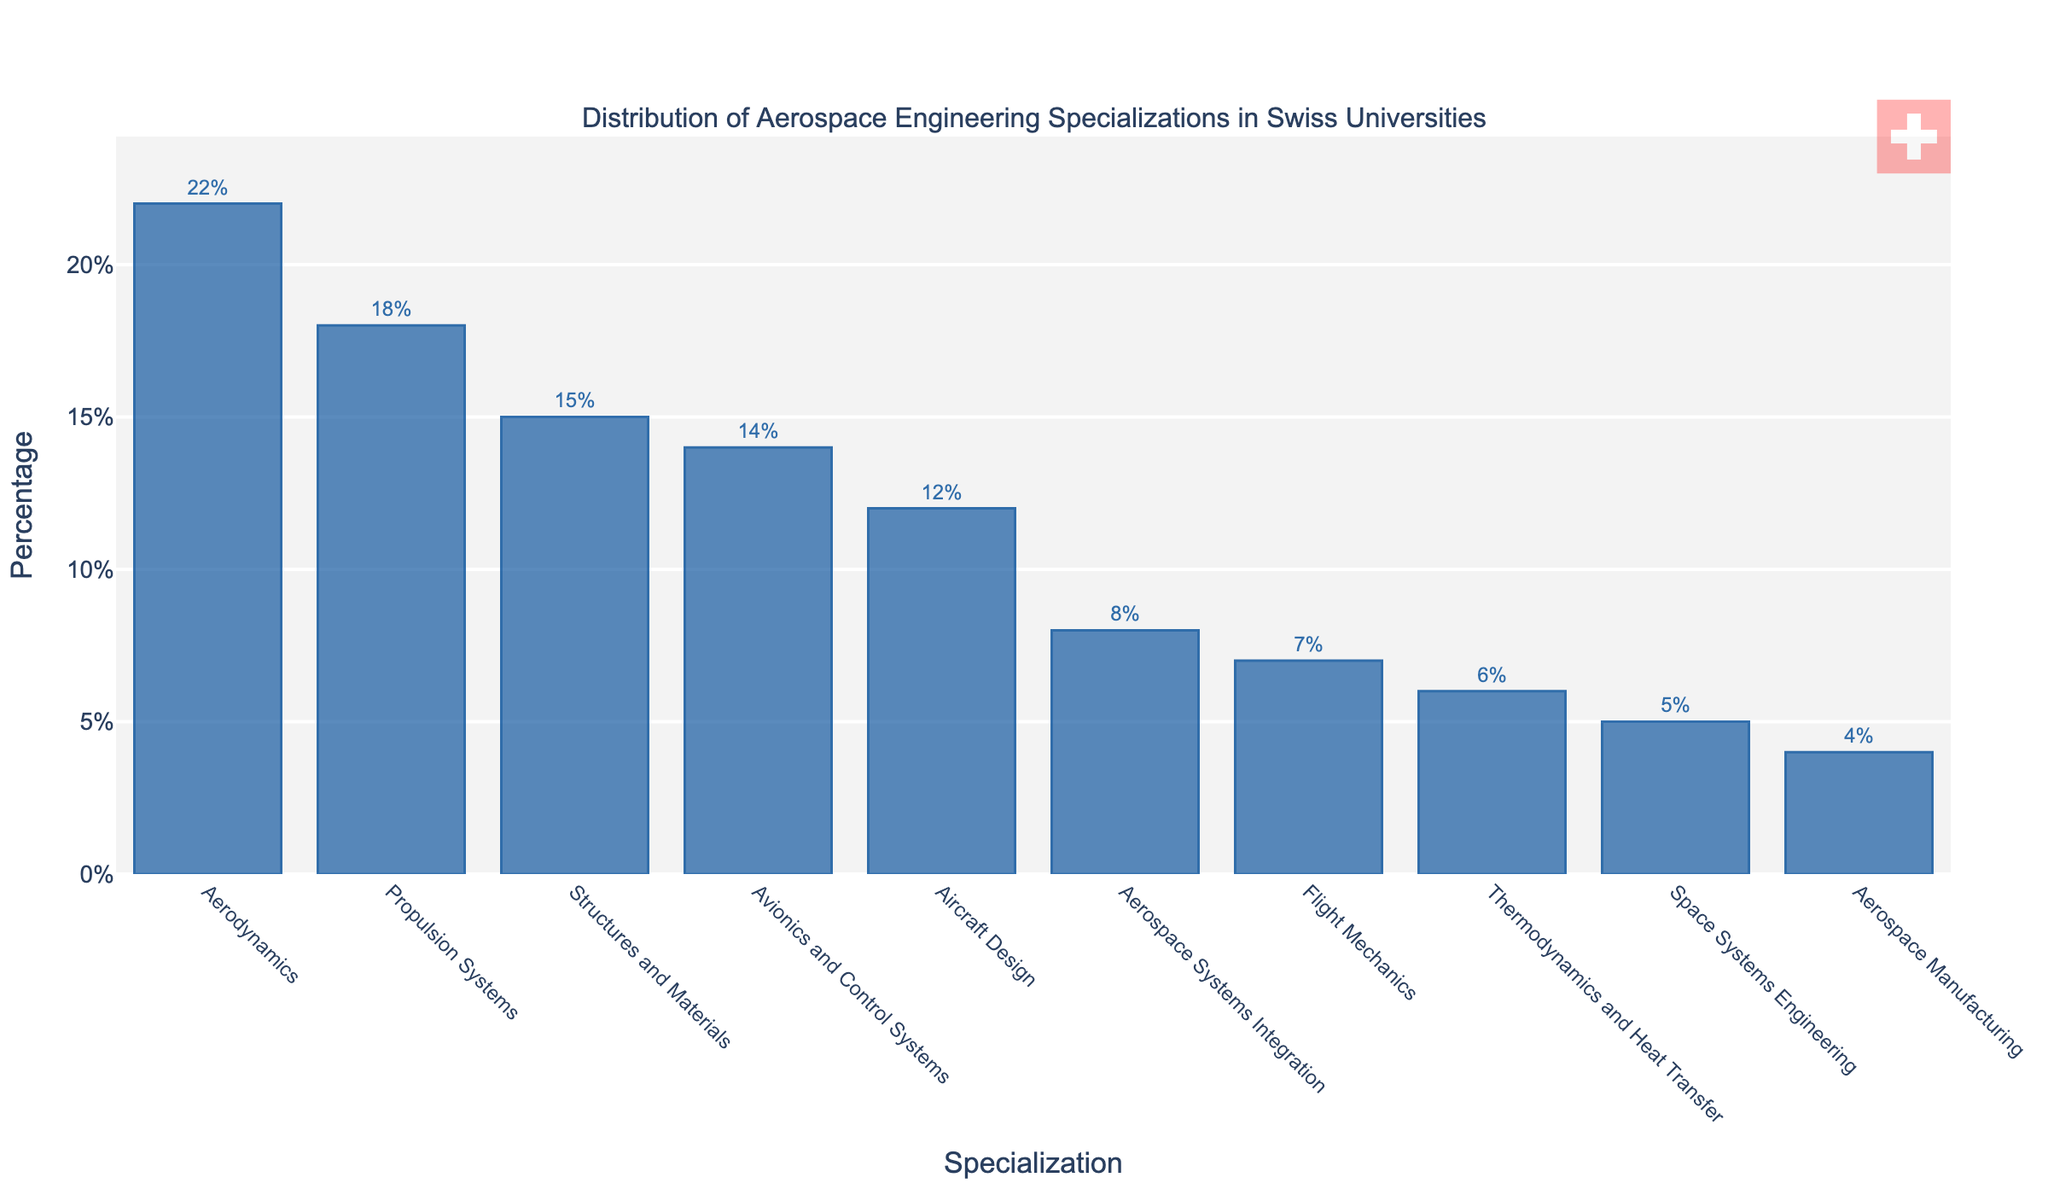What specialization has the highest percentage? The bar representing Aerodynamics is the tallest, indicating it has the highest percentage.
Answer: Aerodynamics Which specializations have a percentage less than 10%? By looking at the bars with heights less than 10%, the specializations are Aerospace Systems Integration, Flight Mechanics, Thermodynamics and Heat Transfer, Space Systems Engineering, and Aerospace Manufacturing.
Answer: Aerospace Systems Integration, Flight Mechanics, Thermodynamics and Heat Transfer, Space Systems Engineering, Aerospace Manufacturing How much higher is the percentage of Aerodynamics compared to Space Systems Engineering? Aerodynamics has a percentage of 22%, and Space Systems Engineering has a percentage of 5%. The difference is 22% - 5% = 17%.
Answer: 17% What is the combined percentage of the top three specializations? The top three specializations are Aerodynamics (22%), Propulsion Systems (18%), and Structures and Materials (15%). The total combined percentage is 22% + 18% + 15% = 55%.
Answer: 55% Which specialization is just less than Aircraft Design in percentage? Avionics and Control Systems has a percentage of 14%, which is just less than Aircraft Design at 12%.
Answer: Aircraft Design What is the average percentage of all listed specializations? Sum all percentages (22 + 18 + 15 + 14 + 12 + 8 + 7 + 6 + 5 + 4 = 111) and divide by the number of specializations (10). The average is 111/10 = 11.1%.
Answer: 11.1% Which is the only specialization with a percentage exactly two points higher than Aerospace Systems Integration? Aerospace Systems Integration is at 8%. The specialization with exactly 2 percentage points higher is Aircraft Design at 12%.
Answer: Aircraft Design How many specializations have a percentage above 15%? Only Aerodynamics, Propulsion Systems, and Structures and Materials have percentages greater than 15%.
Answer: 3 Is the percentage of Flight Mechanics higher, lower, or equal to Aerospace Systems Integration? Flight Mechanics has a percentage of 7%, while Aerospace Systems Integration is at 8%, so Flight Mechanics is lower.
Answer: Lower 